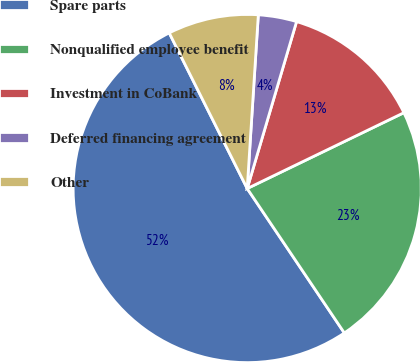<chart> <loc_0><loc_0><loc_500><loc_500><pie_chart><fcel>Spare parts<fcel>Nonqualified employee benefit<fcel>Investment in CoBank<fcel>Deferred financing agreement<fcel>Other<nl><fcel>52.03%<fcel>22.75%<fcel>13.25%<fcel>3.56%<fcel>8.41%<nl></chart> 